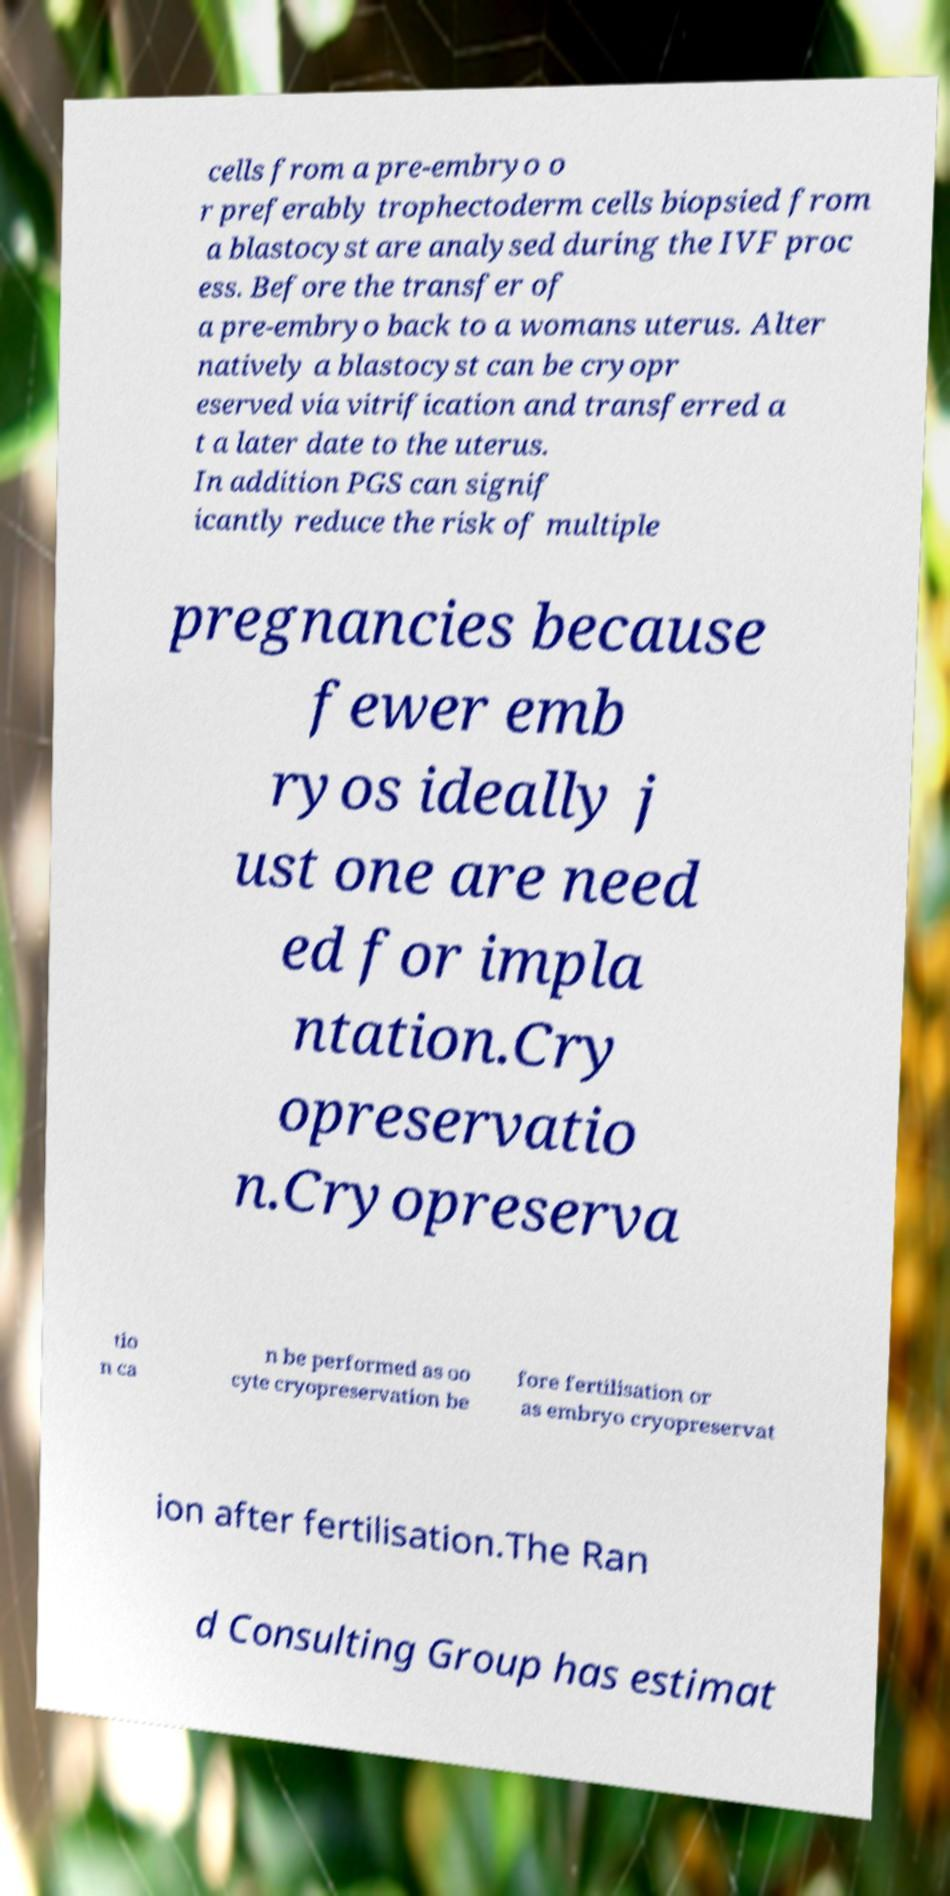What messages or text are displayed in this image? I need them in a readable, typed format. cells from a pre-embryo o r preferably trophectoderm cells biopsied from a blastocyst are analysed during the IVF proc ess. Before the transfer of a pre-embryo back to a womans uterus. Alter natively a blastocyst can be cryopr eserved via vitrification and transferred a t a later date to the uterus. In addition PGS can signif icantly reduce the risk of multiple pregnancies because fewer emb ryos ideally j ust one are need ed for impla ntation.Cry opreservatio n.Cryopreserva tio n ca n be performed as oo cyte cryopreservation be fore fertilisation or as embryo cryopreservat ion after fertilisation.The Ran d Consulting Group has estimat 